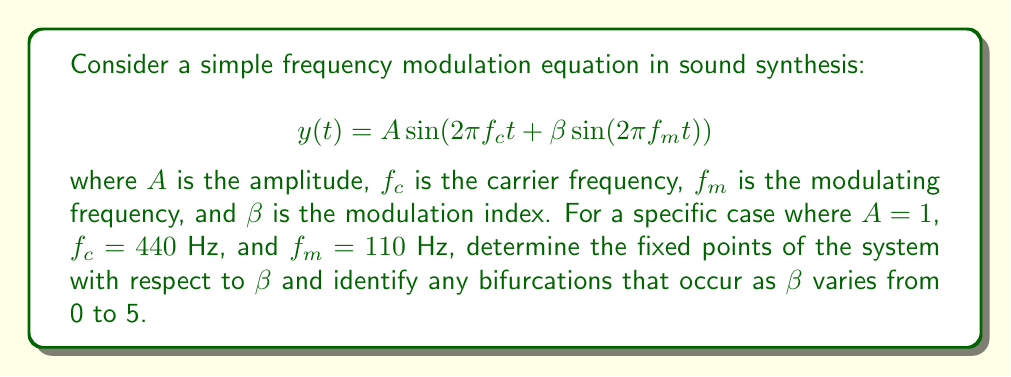Give your solution to this math problem. 1. First, we need to understand that fixed points in this context refer to values of $\beta$ where the behavior of the system changes qualitatively.

2. The frequency modulation equation given is time-dependent, so we need to consider its envelope or overall behavior rather than specific time points.

3. When $\beta = 0$, the equation simplifies to:
   $$y(t) = \sin(2\pi f_c t)$$
   This represents a simple sine wave at the carrier frequency.

4. As $\beta$ increases from 0, sidebands appear in the frequency spectrum at $f_c \pm nf_m$, where $n$ is an integer.

5. The amplitude of these sidebands is determined by Bessel functions of the first kind, $J_n(\beta)$.

6. A significant change in behavior occurs when the first-order sidebands ($n = \pm 1$) become more prominent than the carrier frequency. This happens when:
   $$J_1(\beta) > J_0(\beta)$$

7. Numerically solving this equation, we find that this occurs at approximately $\beta \approx 1.43$.

8. Another significant change occurs when the second-order sidebands ($n = \pm 2$) become more prominent than the first-order sidebands:
   $$J_2(\beta) > J_1(\beta)$$
   This occurs at approximately $\beta \approx 2.63$.

9. These points where the dominant frequency components change can be considered bifurcations in the system's behavior.

10. As $\beta$ continues to increase, more bifurcations occur as higher-order sidebands become dominant, but these become less distinct and harder to pinpoint exactly.
Answer: Fixed points: $\beta \approx 0$ (no modulation), $1.43$ (first bifurcation), $2.63$ (second bifurcation). Bifurcations occur as $\beta$ increases, with significant changes at these points. 